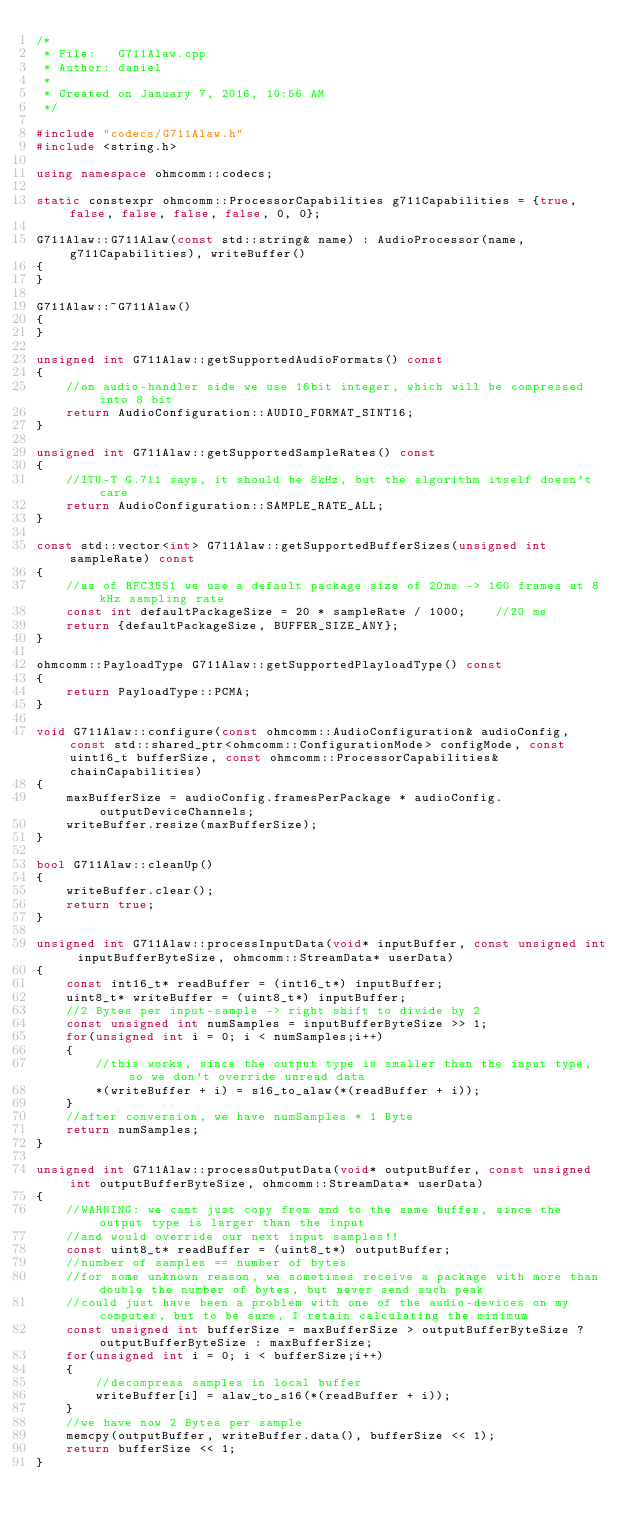<code> <loc_0><loc_0><loc_500><loc_500><_C++_>/* 
 * File:   G711Alaw.cpp
 * Author: daniel
 * 
 * Created on January 7, 2016, 10:56 AM
 */

#include "codecs/G711Alaw.h"
#include <string.h>

using namespace ohmcomm::codecs;

static constexpr ohmcomm::ProcessorCapabilities g711Capabilities = {true, false, false, false, false, 0, 0};

G711Alaw::G711Alaw(const std::string& name) : AudioProcessor(name, g711Capabilities), writeBuffer()
{
}

G711Alaw::~G711Alaw()
{
}

unsigned int G711Alaw::getSupportedAudioFormats() const
{
    //on audio-handler side we use 16bit integer, which will be compressed into 8 bit
    return AudioConfiguration::AUDIO_FORMAT_SINT16;
}

unsigned int G711Alaw::getSupportedSampleRates() const
{
    //ITU-T G.711 says, it should be 8kHz, but the algorithm itself doesn't care
    return AudioConfiguration::SAMPLE_RATE_ALL;
}

const std::vector<int> G711Alaw::getSupportedBufferSizes(unsigned int sampleRate) const
{
    //as of RFC3551 we use a default package size of 20ms -> 160 frames at 8kHz sampling rate
    const int defaultPackageSize = 20 * sampleRate / 1000;    //20 ms
    return {defaultPackageSize, BUFFER_SIZE_ANY};
}

ohmcomm::PayloadType G711Alaw::getSupportedPlayloadType() const
{
    return PayloadType::PCMA;
}

void G711Alaw::configure(const ohmcomm::AudioConfiguration& audioConfig, const std::shared_ptr<ohmcomm::ConfigurationMode> configMode, const uint16_t bufferSize, const ohmcomm::ProcessorCapabilities& chainCapabilities)
{
    maxBufferSize = audioConfig.framesPerPackage * audioConfig.outputDeviceChannels;
    writeBuffer.resize(maxBufferSize);
}

bool G711Alaw::cleanUp()
{
    writeBuffer.clear();
    return true;
}

unsigned int G711Alaw::processInputData(void* inputBuffer, const unsigned int inputBufferByteSize, ohmcomm::StreamData* userData)
{
    const int16_t* readBuffer = (int16_t*) inputBuffer;
    uint8_t* writeBuffer = (uint8_t*) inputBuffer;
    //2 Bytes per input-sample -> right shift to divide by 2
    const unsigned int numSamples = inputBufferByteSize >> 1;
    for(unsigned int i = 0; i < numSamples;i++)
    {
        //this works, since the output type is smaller than the input type, so we don't override unread data
        *(writeBuffer + i) = s16_to_alaw(*(readBuffer + i));
    }
    //after conversion, we have numSamples * 1 Byte
    return numSamples;
}

unsigned int G711Alaw::processOutputData(void* outputBuffer, const unsigned int outputBufferByteSize, ohmcomm::StreamData* userData)
{
    //WARNING: we cant just copy from and to the same buffer, since the output type is larger than the input
    //and would override our next input samples!!
    const uint8_t* readBuffer = (uint8_t*) outputBuffer;
    //number of samples == number of bytes
    //for some unknown reason, we sometimes receive a package with more than double the number of bytes, but never send such peak
    //could just have been a problem with one of the audio-devices on my computer, but to be sure, I retain calculating the minimum
    const unsigned int bufferSize = maxBufferSize > outputBufferByteSize ? outputBufferByteSize : maxBufferSize;
    for(unsigned int i = 0; i < bufferSize;i++)
    {
        //decompress samples in local buffer
        writeBuffer[i] = alaw_to_s16(*(readBuffer + i));
    }
    //we have now 2 Bytes per sample
    memcpy(outputBuffer, writeBuffer.data(), bufferSize << 1);
    return bufferSize << 1;
}</code> 